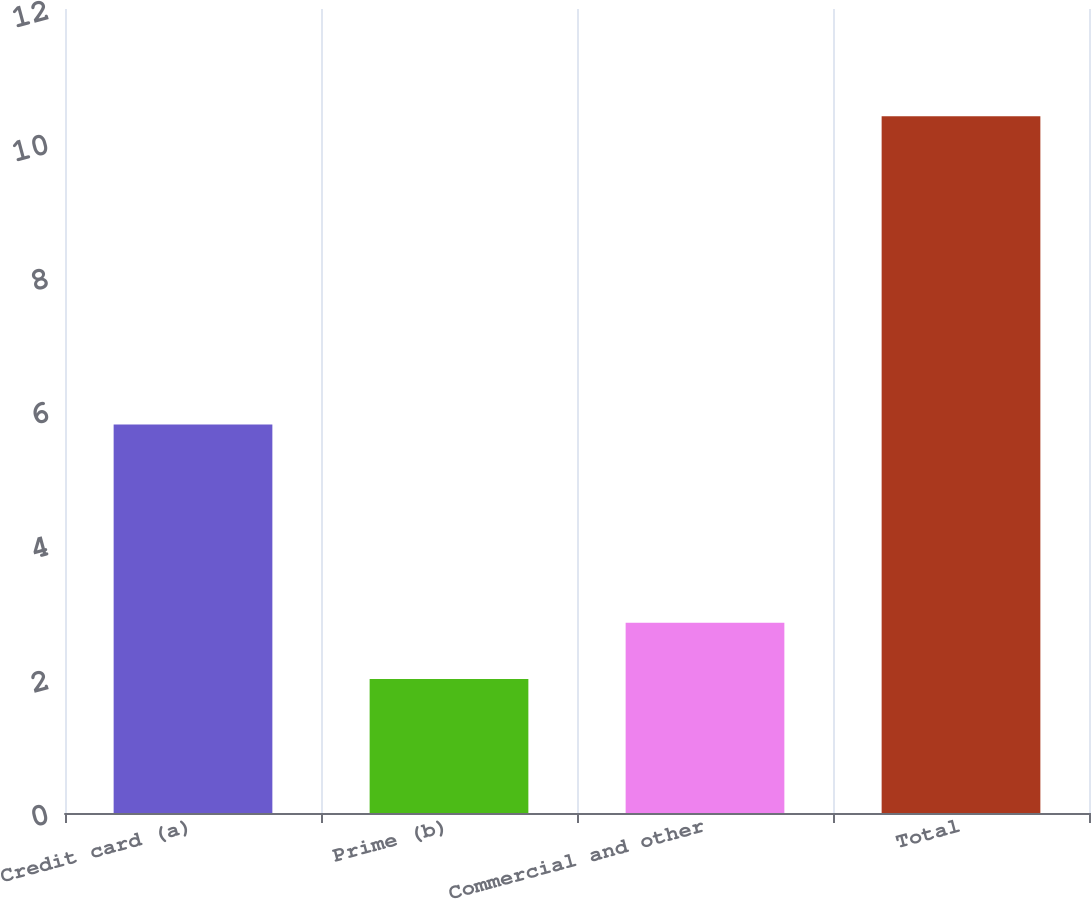Convert chart. <chart><loc_0><loc_0><loc_500><loc_500><bar_chart><fcel>Credit card (a)<fcel>Prime (b)<fcel>Commercial and other<fcel>Total<nl><fcel>5.8<fcel>2<fcel>2.84<fcel>10.4<nl></chart> 